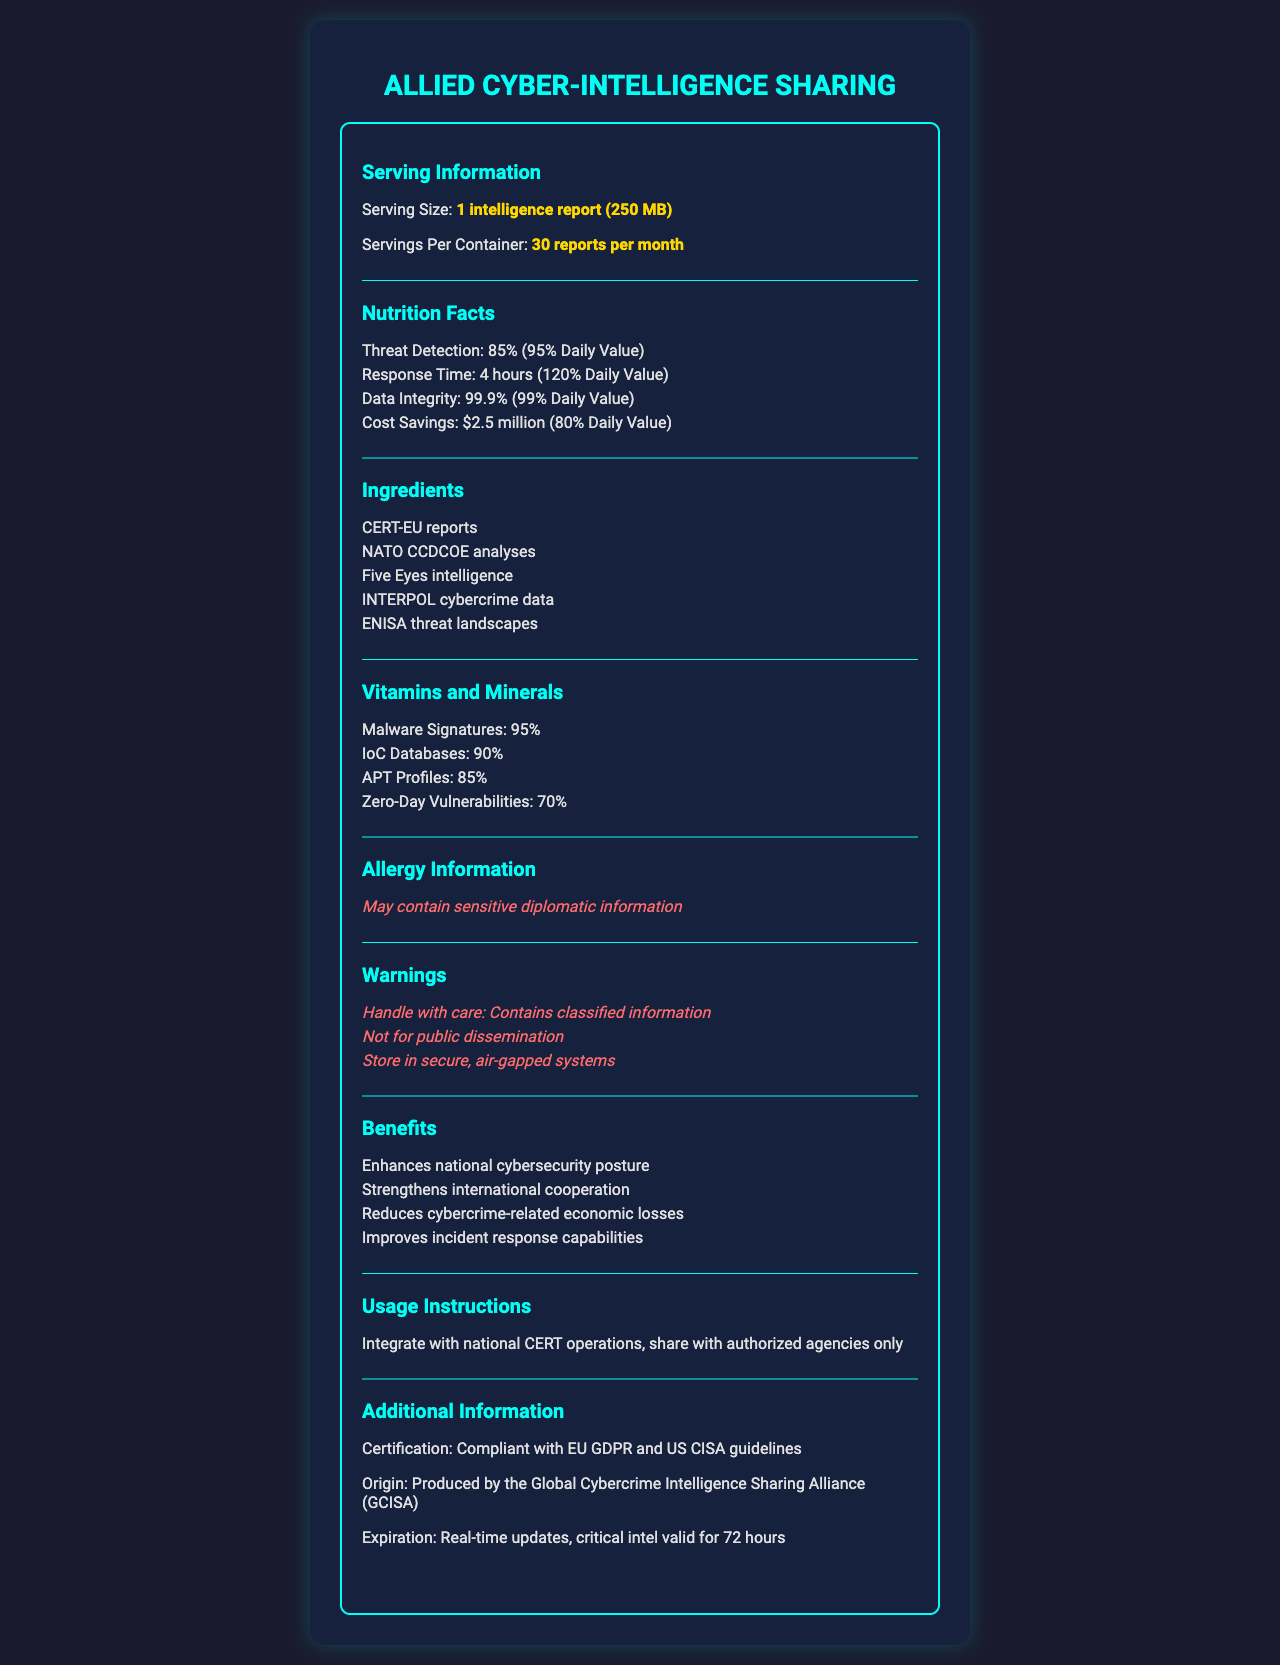what is the serving size of the product? The document states that the serving size is "1 intelligence report (250 MB)" in the Serving Information section.
Answer: 1 intelligence report (250 MB) how many servings are in a container per month? The document mentions in the Serving Information section that there are "30 reports per month" per container.
Answer: 30 reports per month what is the daily value percentage of threat detection? In the Nutrition Facts section, the daily value for Threat Detection is listed as 95%.
Answer: 95% how much cost savings is provided by this product? The Nutrition Facts section indicates that the product provides cost savings amounting to "$2.5 million".
Answer: $2.5 million what does "IoC" stand for in the vitamins and minerals section? IoC stands for Indicators of Compromise, commonly listed in cybersecurity documents.
Answer: Indicators of Compromise which of the following is NOT an ingredient of this product? A. CERT-EU reports B. NATO CCDCOE analyses C. WHO health reports D. Five Eyes intelligence The Ingredients section lists "CERT-EU reports, NATO CCDCOE analyses, Five Eyes intelligence, INTERPOL cybercrime data, ENISA threat landscapes," but does not include WHO health reports.
Answer: C. WHO health reports how long is the response time according to the nutrition facts? The Nutrition Facts section lists the Response Time as "4 hours".
Answer: 4 hours does the document provide usage instructions for the product? The Usage Instructions section provides details on how to use the product: "Integrate with national CERT operations, share with authorized agencies only".
Answer: Yes summarize the main purpose of the document. The document showcases the value and benefits of sharing cyber-intelligence among allied nations, including enhanced threat detection, response time, data integrity, and cost savings. It also offers ingredients, vitamins, minerals, warnings, and usage instructions.
Answer: The document provides detailed information on the nutritional value of cyber-intelligence sharing among allied nations, emphasizing its benefits and instructions for use. is there any warning about handling the product? The Warnings section mentions multiple cautions: "Handle with care: Contains classified information," "Not for public dissemination," and "Store in secure, air-gapped systems".
Answer: Yes which vitamin or mineral has the lowest daily value percentage? A. Malware Signatures B. IoC Databases C. APT Profiles D. Zero-Day Vulnerabilities In the Vitamins and Minerals section, Zero-Day Vulnerabilities have a daily value percentage of 70%, which is the lowest among the listed items.
Answer: D. Zero-Day Vulnerabilities does the document specify the origin of the product? The document specifies the origin of the product in the Additional Information section, stating that it is "Produced by the Global Cybercrime Intelligence Sharing Alliance (GCISA)".
Answer: Yes what certification does the product comply with? According to the Additional Information section, the product is "Compliant with EU GDPR and US CISA guidelines."
Answer: EU GDPR and US CISA guidelines what is the amount of data integrity provided by this product? The Nutrition Facts section mentions that the product offers data integrity of "99.9%."
Answer: 99.9% how often does the product receive updates? The Expiration section states, "Real-time updates, critical intel valid for 72 hours."
Answer: Real-time which organization does NOT appear in the ingredients list? A. CERT-EU B. NATO CCDCOE C. INCIBE D. INTERPOL The Ingredients section lists "CERT-EU reports, NATO CCDCOE analyses, Five Eyes intelligence, INTERPOL cybercrime data, ENISA threat landscapes," but does not include INCIBE.
Answer: C. INCIBE how should the product be stored? One of the warnings advises to "Store in secure, air-gapped systems."
Answer: In secure, air-gapped systems what does the allergy information suggest? The Allergy Information section warns that the product "May contain sensitive diplomatic information."
Answer: May contain sensitive diplomatic information can the document determine the specific countries involved in the intelligence sharing? The document lists organizations and alliances but does not specify the individual countries involved in the intelligence sharing.
Answer: Not enough information 